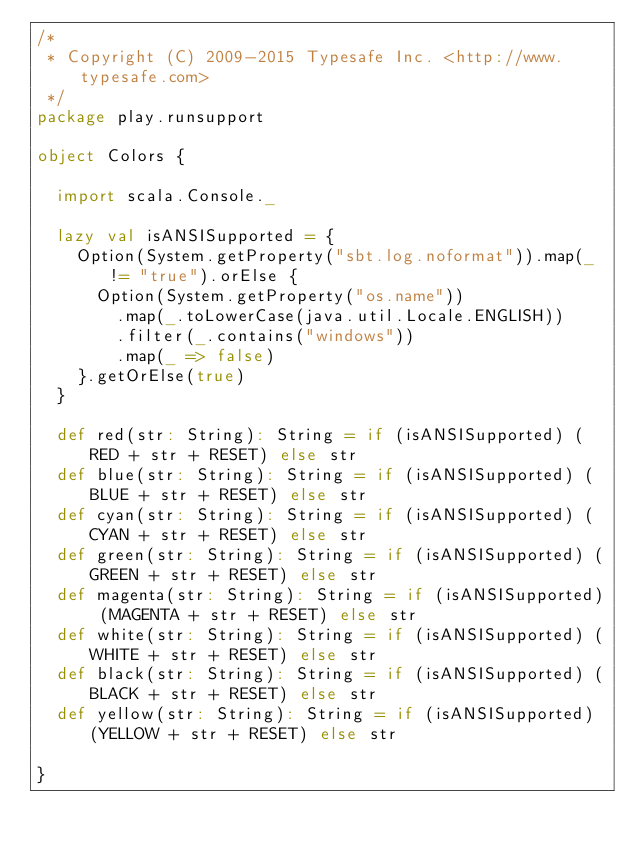Convert code to text. <code><loc_0><loc_0><loc_500><loc_500><_Scala_>/*
 * Copyright (C) 2009-2015 Typesafe Inc. <http://www.typesafe.com>
 */
package play.runsupport

object Colors {

  import scala.Console._

  lazy val isANSISupported = {
    Option(System.getProperty("sbt.log.noformat")).map(_ != "true").orElse {
      Option(System.getProperty("os.name"))
        .map(_.toLowerCase(java.util.Locale.ENGLISH))
        .filter(_.contains("windows"))
        .map(_ => false)
    }.getOrElse(true)
  }

  def red(str: String): String = if (isANSISupported) (RED + str + RESET) else str
  def blue(str: String): String = if (isANSISupported) (BLUE + str + RESET) else str
  def cyan(str: String): String = if (isANSISupported) (CYAN + str + RESET) else str
  def green(str: String): String = if (isANSISupported) (GREEN + str + RESET) else str
  def magenta(str: String): String = if (isANSISupported) (MAGENTA + str + RESET) else str
  def white(str: String): String = if (isANSISupported) (WHITE + str + RESET) else str
  def black(str: String): String = if (isANSISupported) (BLACK + str + RESET) else str
  def yellow(str: String): String = if (isANSISupported) (YELLOW + str + RESET) else str

}
</code> 